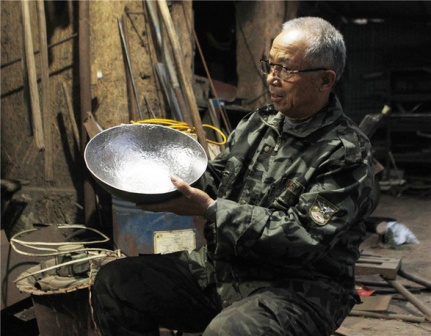Write a detailed description of the given image. In the heart of a packed workshop, an elderly man is intently focused on a large metal bowl he cradles in his hands. His glasses, perched on his nose, catch the light within the workshop. He wears a camouflage jacket, adding a dash of color to the predominantly metallic environment.

The workshop is a rich tapestry of a lifetime's labor, abundant with diverse tools and apparatus scattered around, each with its designated spot in this organized clutter. This setting paints the picture of numerous projects birthed within these walls.

A blue barrel in the backdrop contrasts sharply with the muted tones of the workshop, seemingly drawing attention amidst the plethora of tools and machines.

Despite the apparent disorder, there's an underlying sense of organization. Every piece, from the tiniest screwdriver to the heftiest machinery, has its place. This workspace, with its myriad tools each bearing the signs of past endeavors, tells a story of countless hours of dedicated work.

Although there's no text in the image, the scene narrates a rich story about the man and his craft. The workshop transcends being merely a place of work; it stands as a monument to a life devoted to skill. The man's focused demeanor while holding the metal bowl epitomizes the craftsmanship thriving in this space. It's a snapshot capturing a meaningful moment in the midst of creation. 